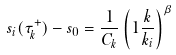Convert formula to latex. <formula><loc_0><loc_0><loc_500><loc_500>s _ { i } ( \tau ^ { + } _ { k } ) - s _ { 0 } = \frac { 1 } { C _ { k } } \left ( 1 \frac { k } { k _ { i } } \right ) ^ { \beta }</formula> 